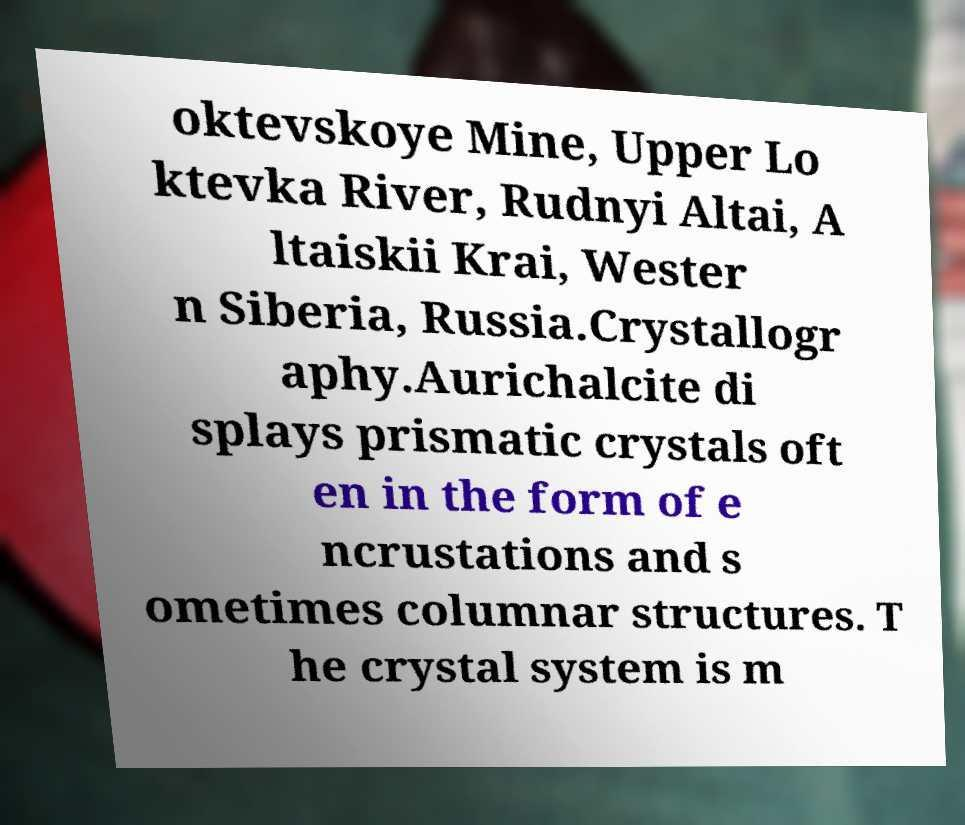Please identify and transcribe the text found in this image. oktevskoye Mine, Upper Lo ktevka River, Rudnyi Altai, A ltaiskii Krai, Wester n Siberia, Russia.Crystallogr aphy.Aurichalcite di splays prismatic crystals oft en in the form of e ncrustations and s ometimes columnar structures. T he crystal system is m 